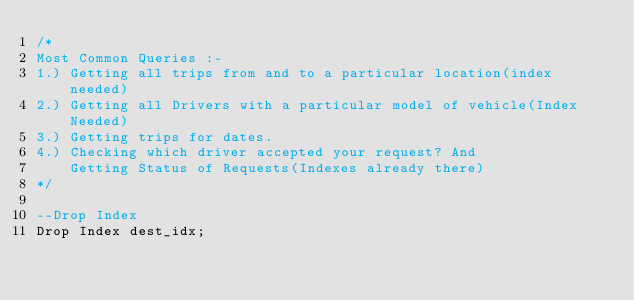Convert code to text. <code><loc_0><loc_0><loc_500><loc_500><_SQL_>/*
Most Common Queries :-
1.) Getting all trips from and to a particular location(index needed)
2.) Getting all Drivers with a particular model of vehicle(Index Needed)
3.) Getting trips for dates.
4.) Checking which driver accepted your request? And
    Getting Status of Requests(Indexes already there)
*/

--Drop Index
Drop Index dest_idx;</code> 